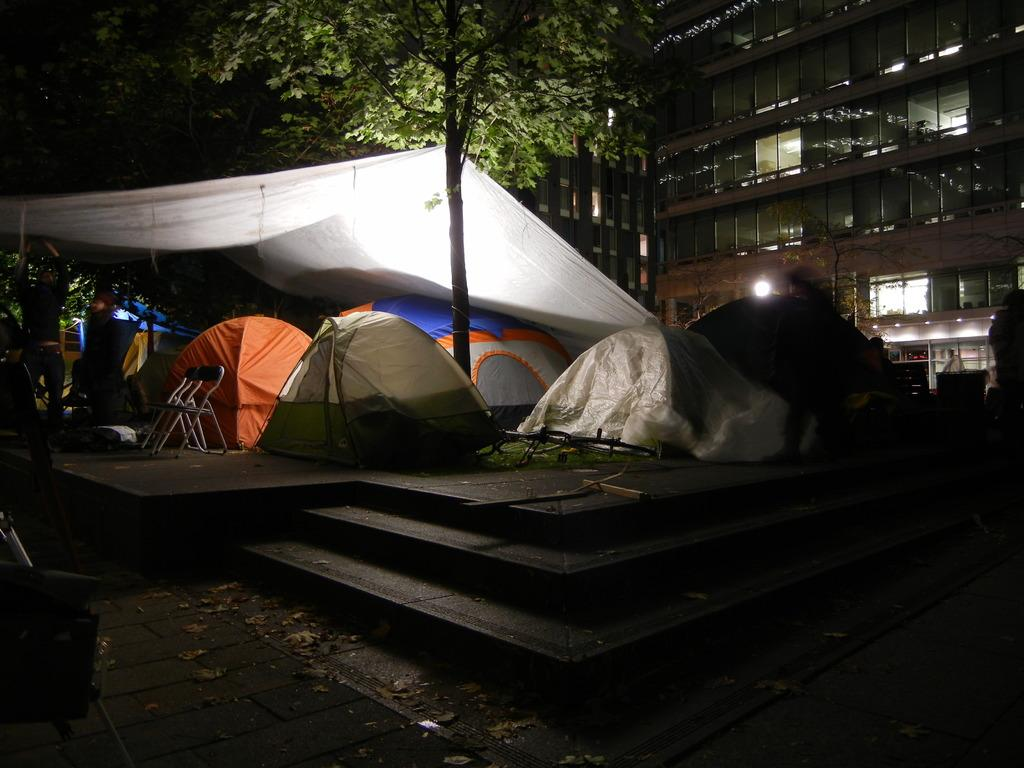What celestial objects can be seen in the image? There are stars visible in the image. What type of temporary shelter is present in the image? There are tents in the image. What structure is located on the right side of the image? There is a building on the right side of the image. What type of vegetation is present in the image? There are trees in the image. Where is the nearest coastline in the image? There is no coastline present in the image. What scientific experiments are being conducted in the image? There is no indication of any scientific experiments being conducted in the image. 